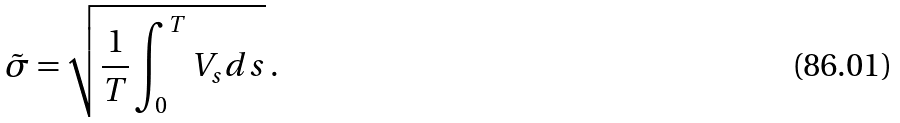<formula> <loc_0><loc_0><loc_500><loc_500>\tilde { \sigma } = \sqrt { \frac { 1 } { T } \int ^ { T } _ { 0 } V _ { s } d s } \, .</formula> 